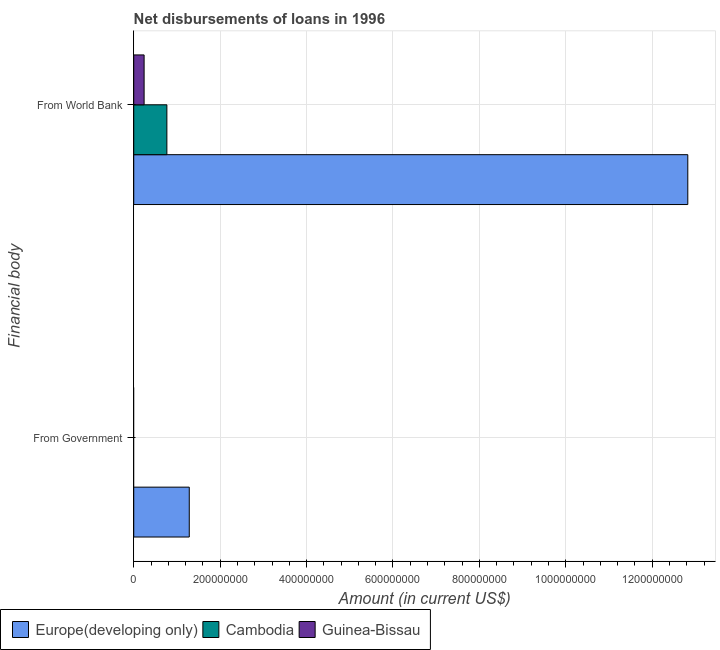How many different coloured bars are there?
Your response must be concise. 3. Are the number of bars per tick equal to the number of legend labels?
Keep it short and to the point. No. Are the number of bars on each tick of the Y-axis equal?
Provide a short and direct response. No. How many bars are there on the 2nd tick from the bottom?
Offer a very short reply. 3. What is the label of the 2nd group of bars from the top?
Ensure brevity in your answer.  From Government. What is the net disbursements of loan from world bank in Europe(developing only)?
Give a very brief answer. 1.28e+09. Across all countries, what is the maximum net disbursements of loan from government?
Your answer should be very brief. 1.29e+08. Across all countries, what is the minimum net disbursements of loan from government?
Ensure brevity in your answer.  0. In which country was the net disbursements of loan from world bank maximum?
Provide a short and direct response. Europe(developing only). What is the total net disbursements of loan from government in the graph?
Your answer should be very brief. 1.29e+08. What is the difference between the net disbursements of loan from world bank in Guinea-Bissau and that in Europe(developing only)?
Your response must be concise. -1.26e+09. What is the difference between the net disbursements of loan from world bank in Guinea-Bissau and the net disbursements of loan from government in Cambodia?
Your response must be concise. 2.40e+07. What is the average net disbursements of loan from world bank per country?
Offer a terse response. 4.61e+08. What is the ratio of the net disbursements of loan from world bank in Cambodia to that in Europe(developing only)?
Your response must be concise. 0.06. Is the net disbursements of loan from world bank in Europe(developing only) less than that in Cambodia?
Provide a succinct answer. No. In how many countries, is the net disbursements of loan from world bank greater than the average net disbursements of loan from world bank taken over all countries?
Provide a succinct answer. 1. How many bars are there?
Make the answer very short. 4. Are all the bars in the graph horizontal?
Make the answer very short. Yes. How many countries are there in the graph?
Your response must be concise. 3. Are the values on the major ticks of X-axis written in scientific E-notation?
Offer a very short reply. No. Does the graph contain any zero values?
Give a very brief answer. Yes. Does the graph contain grids?
Your response must be concise. Yes. How many legend labels are there?
Provide a succinct answer. 3. What is the title of the graph?
Offer a terse response. Net disbursements of loans in 1996. What is the label or title of the X-axis?
Provide a succinct answer. Amount (in current US$). What is the label or title of the Y-axis?
Keep it short and to the point. Financial body. What is the Amount (in current US$) of Europe(developing only) in From Government?
Provide a succinct answer. 1.29e+08. What is the Amount (in current US$) of Cambodia in From Government?
Offer a terse response. 0. What is the Amount (in current US$) of Guinea-Bissau in From Government?
Keep it short and to the point. 0. What is the Amount (in current US$) of Europe(developing only) in From World Bank?
Provide a short and direct response. 1.28e+09. What is the Amount (in current US$) of Cambodia in From World Bank?
Keep it short and to the point. 7.67e+07. What is the Amount (in current US$) in Guinea-Bissau in From World Bank?
Provide a succinct answer. 2.40e+07. Across all Financial body, what is the maximum Amount (in current US$) of Europe(developing only)?
Your response must be concise. 1.28e+09. Across all Financial body, what is the maximum Amount (in current US$) of Cambodia?
Your answer should be compact. 7.67e+07. Across all Financial body, what is the maximum Amount (in current US$) in Guinea-Bissau?
Give a very brief answer. 2.40e+07. Across all Financial body, what is the minimum Amount (in current US$) of Europe(developing only)?
Your answer should be compact. 1.29e+08. Across all Financial body, what is the minimum Amount (in current US$) of Cambodia?
Ensure brevity in your answer.  0. What is the total Amount (in current US$) of Europe(developing only) in the graph?
Provide a short and direct response. 1.41e+09. What is the total Amount (in current US$) in Cambodia in the graph?
Offer a very short reply. 7.67e+07. What is the total Amount (in current US$) in Guinea-Bissau in the graph?
Keep it short and to the point. 2.40e+07. What is the difference between the Amount (in current US$) of Europe(developing only) in From Government and that in From World Bank?
Provide a short and direct response. -1.15e+09. What is the difference between the Amount (in current US$) of Europe(developing only) in From Government and the Amount (in current US$) of Cambodia in From World Bank?
Keep it short and to the point. 5.19e+07. What is the difference between the Amount (in current US$) of Europe(developing only) in From Government and the Amount (in current US$) of Guinea-Bissau in From World Bank?
Make the answer very short. 1.05e+08. What is the average Amount (in current US$) in Europe(developing only) per Financial body?
Provide a short and direct response. 7.05e+08. What is the average Amount (in current US$) of Cambodia per Financial body?
Provide a succinct answer. 3.83e+07. What is the average Amount (in current US$) of Guinea-Bissau per Financial body?
Offer a very short reply. 1.20e+07. What is the difference between the Amount (in current US$) of Europe(developing only) and Amount (in current US$) of Cambodia in From World Bank?
Keep it short and to the point. 1.21e+09. What is the difference between the Amount (in current US$) of Europe(developing only) and Amount (in current US$) of Guinea-Bissau in From World Bank?
Give a very brief answer. 1.26e+09. What is the difference between the Amount (in current US$) in Cambodia and Amount (in current US$) in Guinea-Bissau in From World Bank?
Give a very brief answer. 5.27e+07. What is the ratio of the Amount (in current US$) in Europe(developing only) in From Government to that in From World Bank?
Ensure brevity in your answer.  0.1. What is the difference between the highest and the second highest Amount (in current US$) in Europe(developing only)?
Make the answer very short. 1.15e+09. What is the difference between the highest and the lowest Amount (in current US$) in Europe(developing only)?
Make the answer very short. 1.15e+09. What is the difference between the highest and the lowest Amount (in current US$) in Cambodia?
Give a very brief answer. 7.67e+07. What is the difference between the highest and the lowest Amount (in current US$) in Guinea-Bissau?
Ensure brevity in your answer.  2.40e+07. 